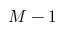<formula> <loc_0><loc_0><loc_500><loc_500>M - 1</formula> 